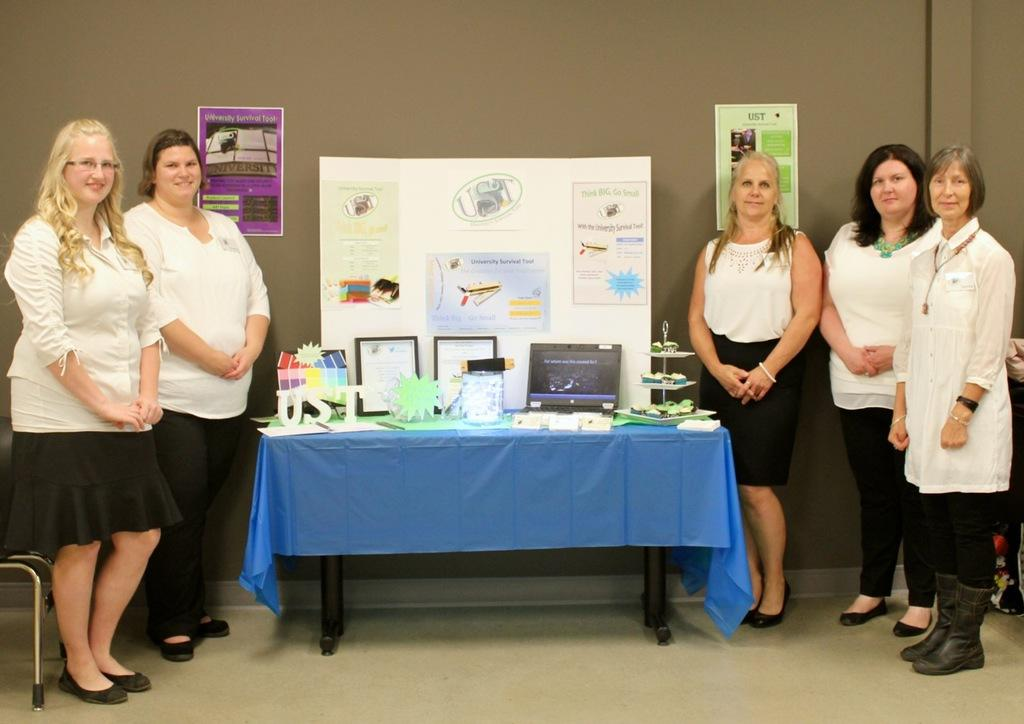How many women are on the left side of the image? There are two women on the left side of the image. How many women are on the right side of the image? There are three women on the right side of the image. What is between the women? There is a table between the women. What objects can be seen on the table? Frames, a laptop, and paper-made things are on the table. What is on the wall in the image? There are posters on the wall. What type of pickle is being used as a prop in the image? There is no pickle present in the image. Can you see any evidence of magic being performed in the image? There is no indication of magic being performed in the image. 